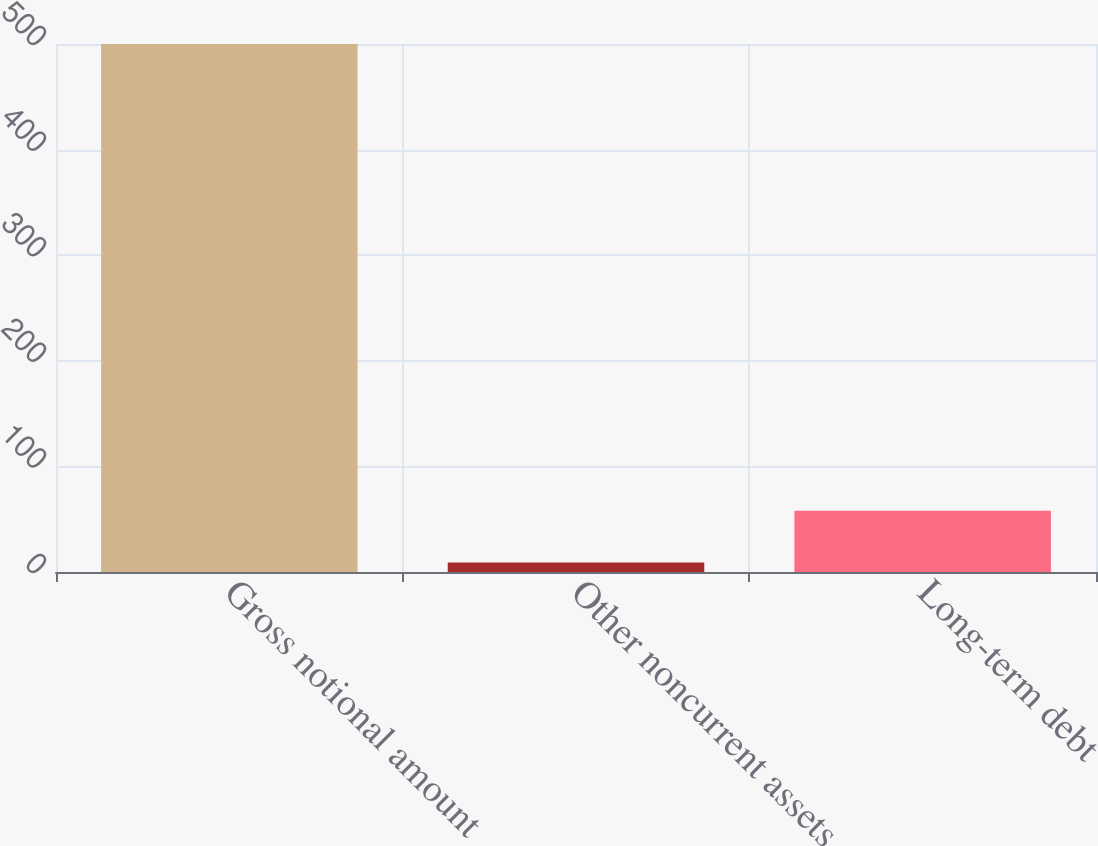<chart> <loc_0><loc_0><loc_500><loc_500><bar_chart><fcel>Gross notional amount<fcel>Other noncurrent assets<fcel>Long-term debt<nl><fcel>500<fcel>9<fcel>58.1<nl></chart> 